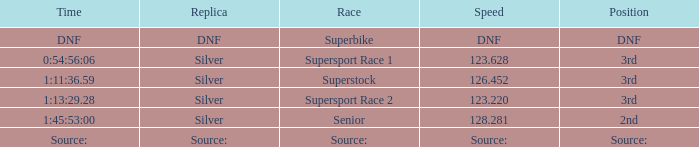Which race has a replica of DNF? Superbike. 